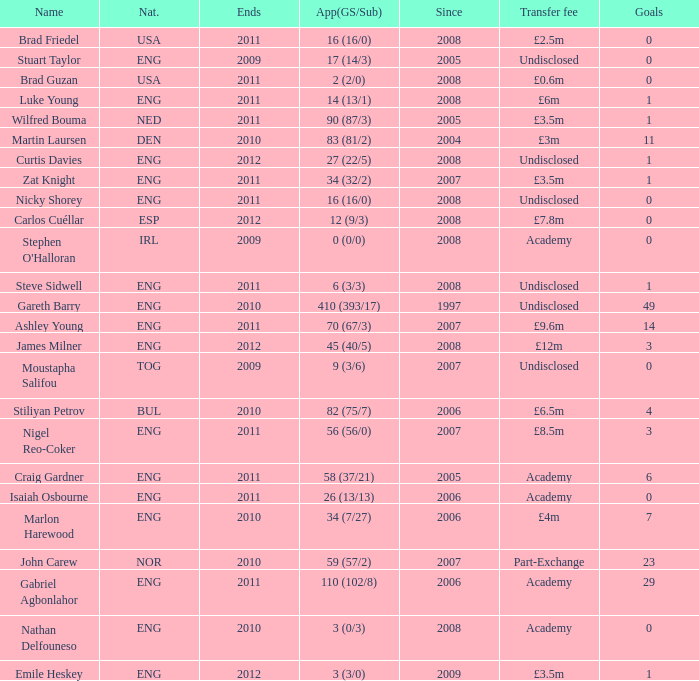When the transfer fee is £8.5m, what is the total ends? 2011.0. 